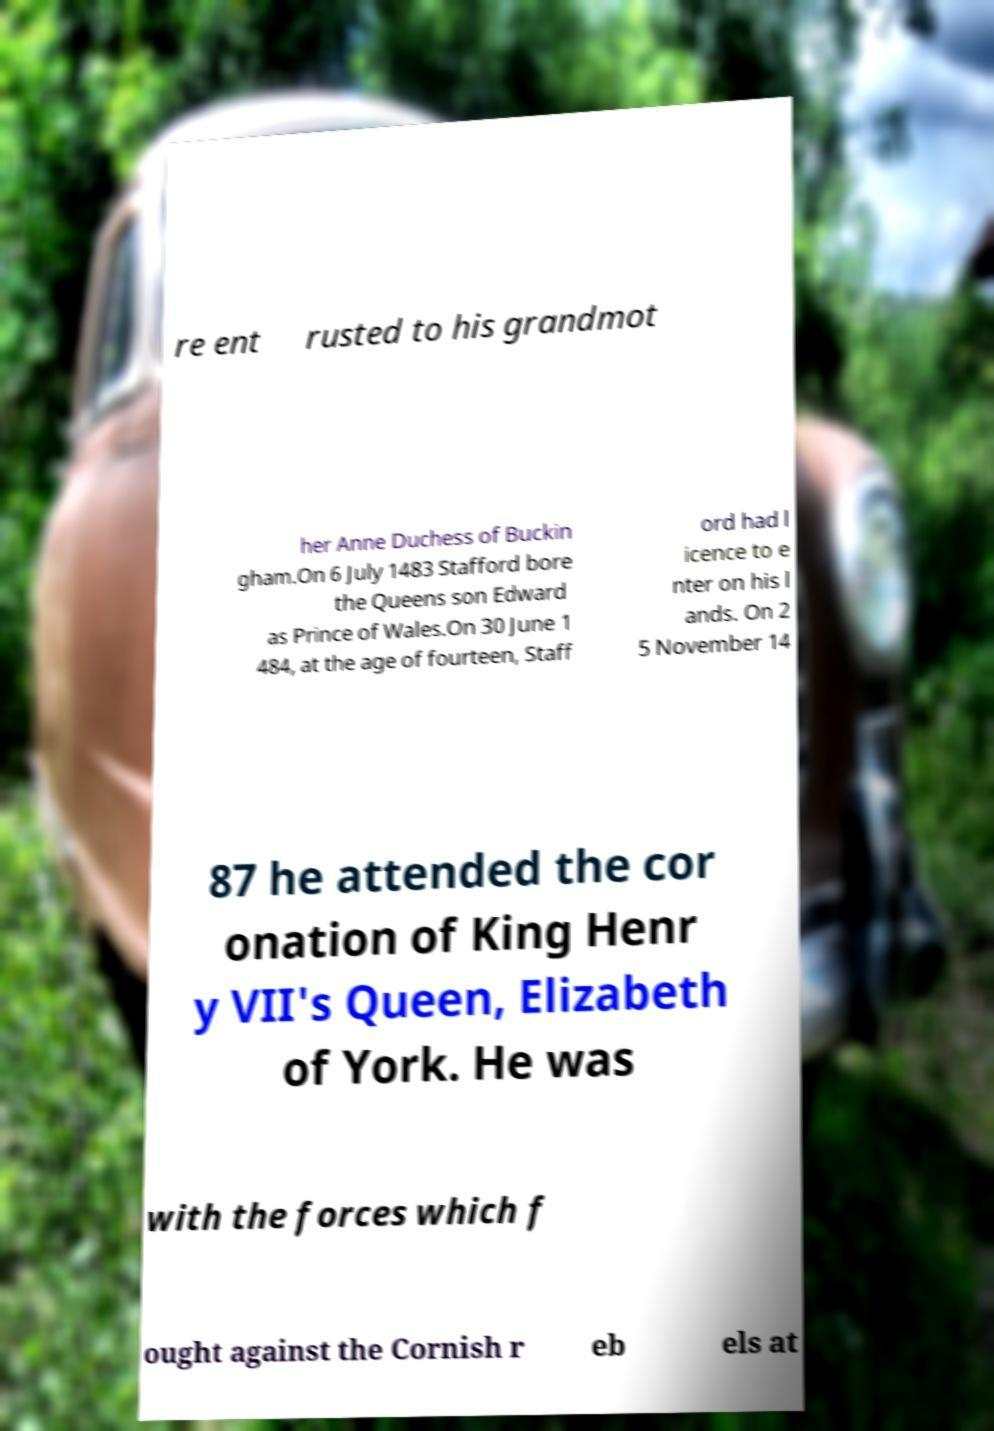Please identify and transcribe the text found in this image. re ent rusted to his grandmot her Anne Duchess of Buckin gham.On 6 July 1483 Stafford bore the Queens son Edward as Prince of Wales.On 30 June 1 484, at the age of fourteen, Staff ord had l icence to e nter on his l ands. On 2 5 November 14 87 he attended the cor onation of King Henr y VII's Queen, Elizabeth of York. He was with the forces which f ought against the Cornish r eb els at 